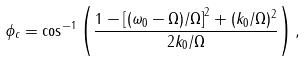<formula> <loc_0><loc_0><loc_500><loc_500>\phi _ { c } = \cos ^ { - 1 } \left ( \frac { 1 - \left [ ( \omega _ { 0 } - \Omega ) / \Omega \right ] ^ { 2 } + ( k _ { 0 } / \Omega ) ^ { 2 } } { 2 k _ { 0 } / \Omega } \right ) ,</formula> 